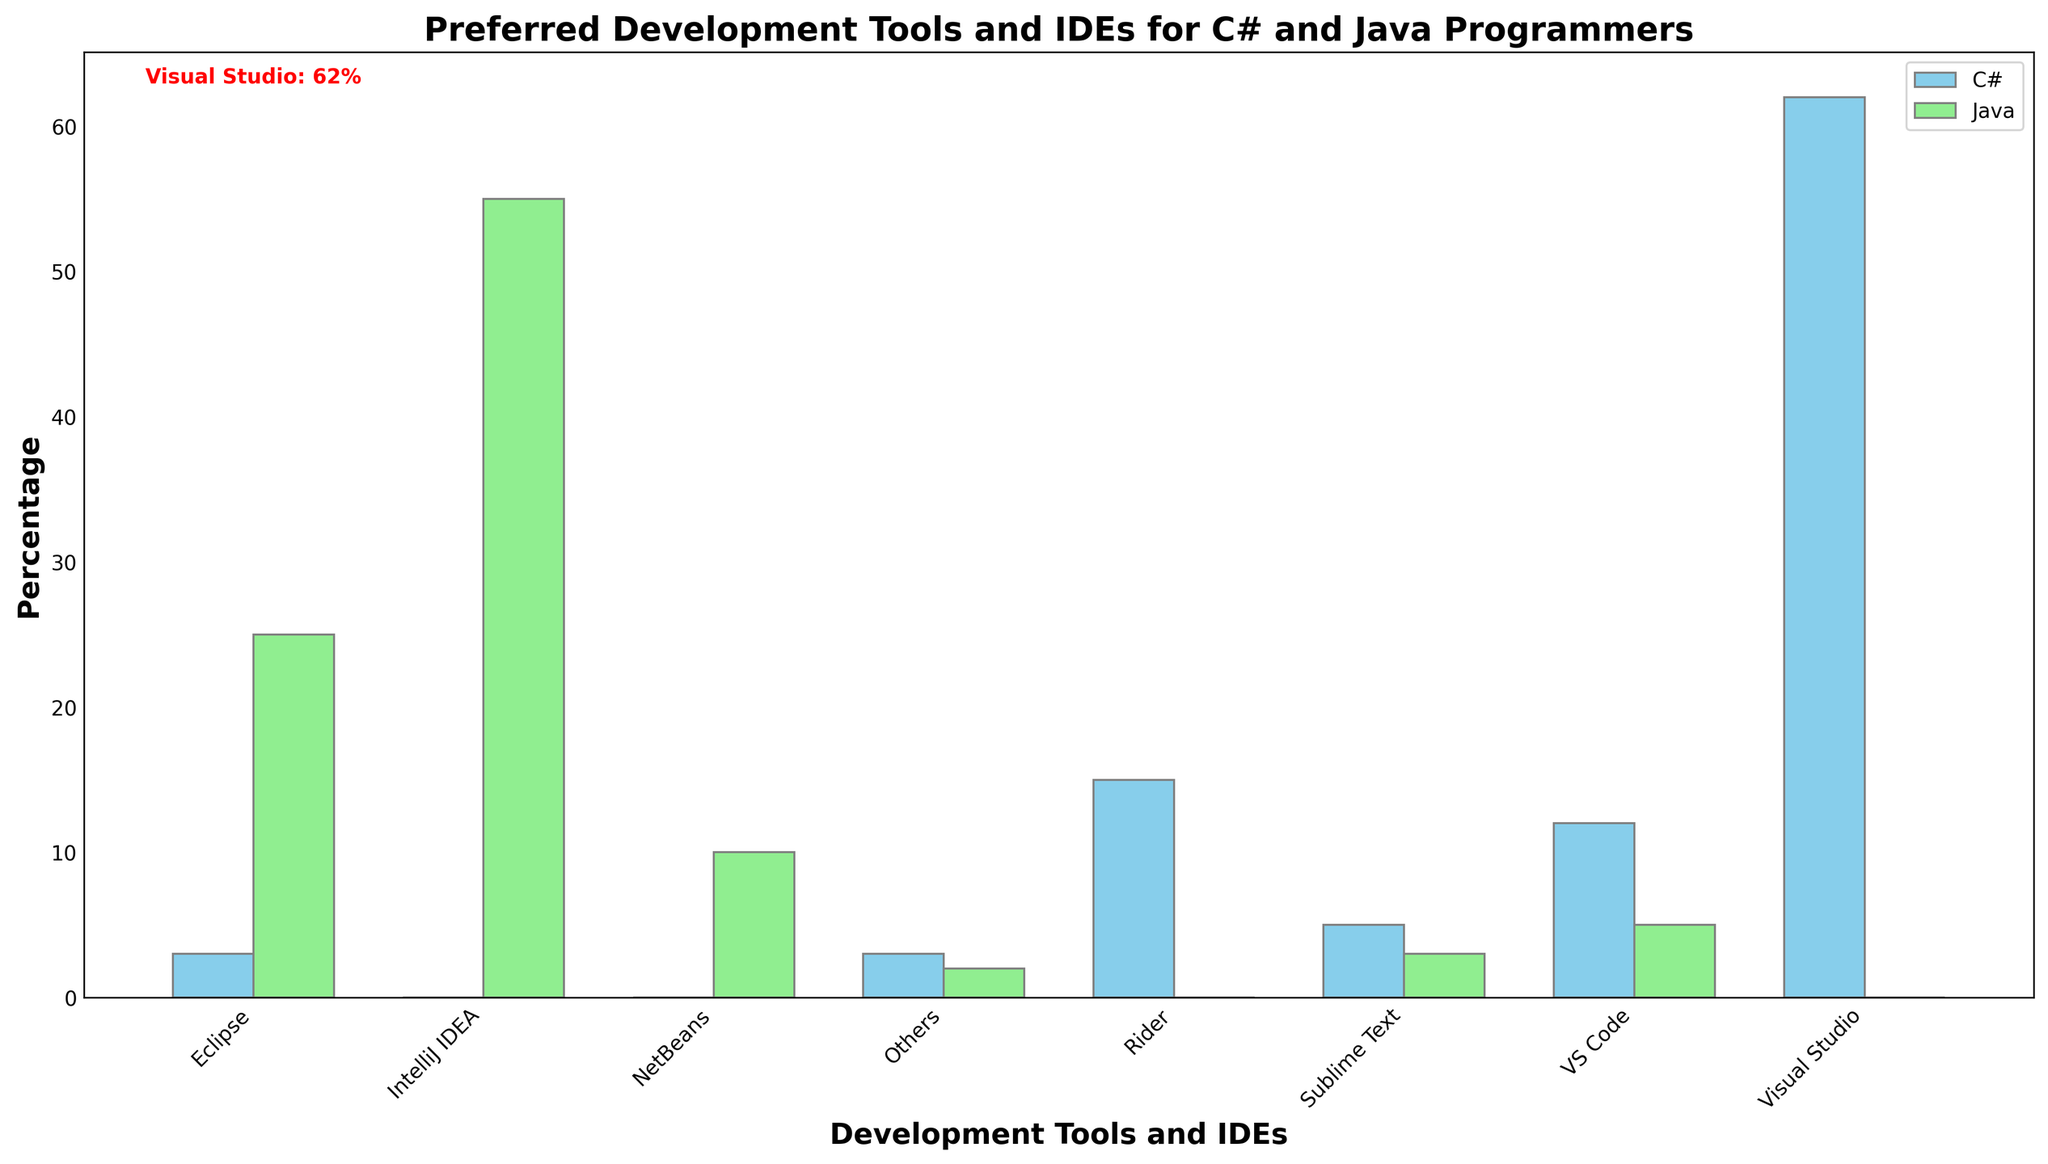What is the most preferred development tool for C# programmers? The highest bar in the C# category is for Visual Studio, and it has the highest percentage mentioned in red text annotation.
Answer: Visual Studio What is the percentage difference between Visual Studio for C# and IntelliJ IDEA for Java? Visual Studio for C# has 62%, and IntelliJ IDEA for Java has 55%. The difference is calculated as 62% - 55% = 7%.
Answer: 7% Which tool is more preferred by Java programmers compared to C# programmers? The bars for Java show that IntelliJ IDEA, with 55%, is preferred more by Java programmers because, for C#, it is not one of the top tools.
Answer: IntelliJ IDEA Which tools have the same percentage usage among C# and Java programmers? By looking at the bars, only VS Code has the same height for both C# and Java, each with a percentage of 5%.
Answer: VS Code What is the average percentage usage of all tools among C# programmers? Summing the percentages for C# tools: 62 + 15 + 12 + 5 + 3 + 3 = 100%. The average is 100% / 6 = 16.67%.
Answer: 16.67% How does VS Code compare in usage between C# and Java programmers? Both have a 5% usage for VS Code, as indicated by the equal heights of the bars.
Answer: Equal What is the least used development tool among Java programmers? The shortest bar in the Java category represents 'Others' with 2%.
Answer: Others Which development tool has the maximum percentage, and what is it? Visual Studio for C# has the maximum percentage at 62%, highlighted with red text annotation.
Answer: Visual Studio (62%) Among Eclipse, VS Code, and Sublime Text, which tool has the highest percentage for Java programmers? By comparing the heights of bars, Eclipse has 25%, which is higher than VS Code's 5% and Sublime Text's 3%.
Answer: Eclipse (25%) What is the total percentage for non-mainstream tools (Sublime Text, Others) among all Java programmers? Sum of Sublime Text (3%) and Others (2%) for Java: 3% + 2% = 5%.
Answer: 5% 